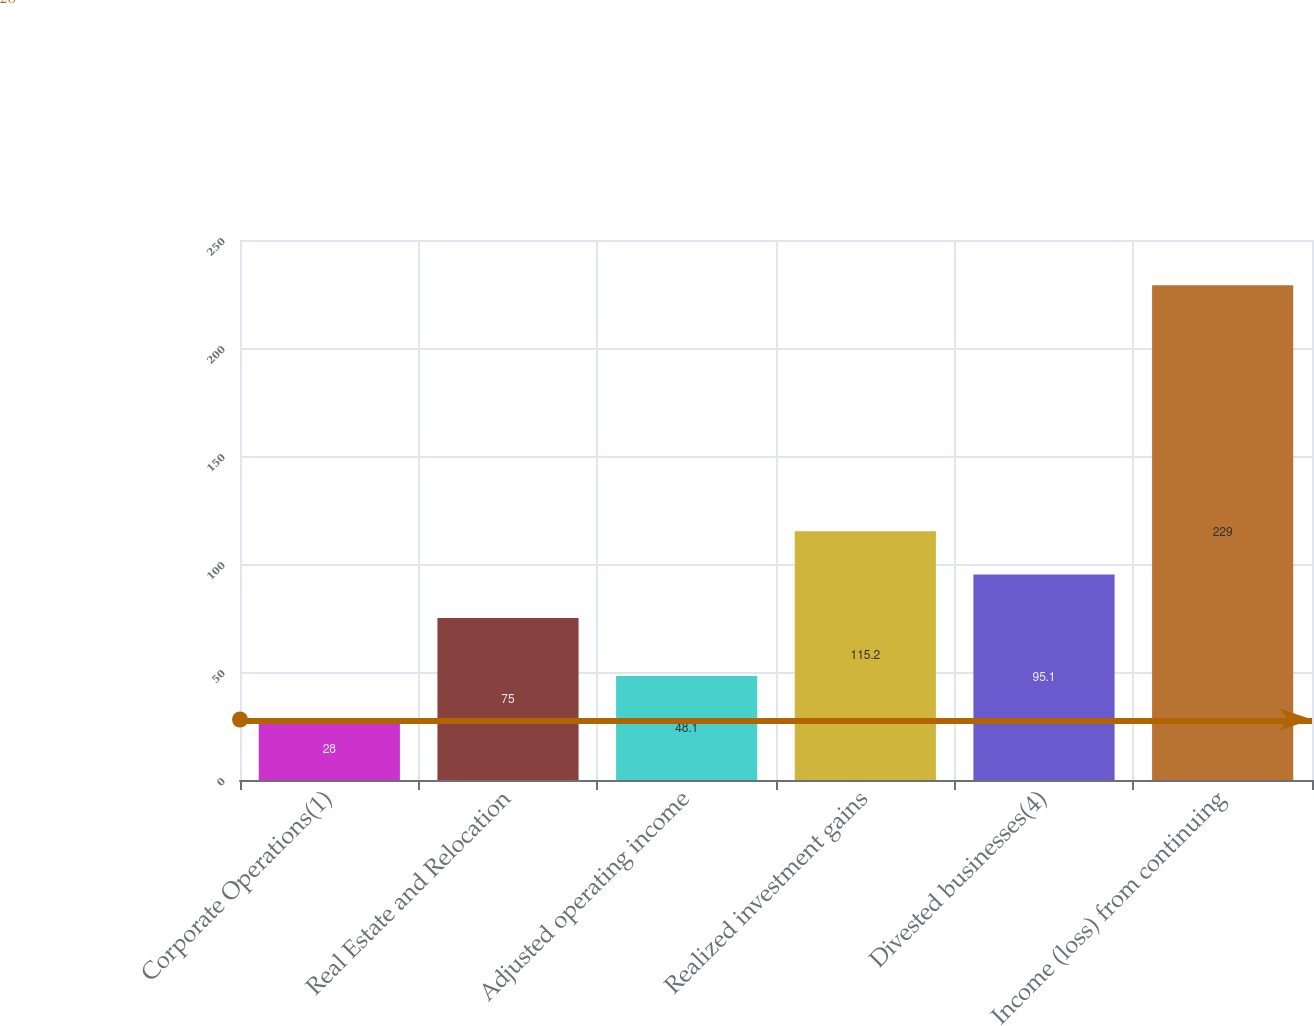<chart> <loc_0><loc_0><loc_500><loc_500><bar_chart><fcel>Corporate Operations(1)<fcel>Real Estate and Relocation<fcel>Adjusted operating income<fcel>Realized investment gains<fcel>Divested businesses(4)<fcel>Income (loss) from continuing<nl><fcel>28<fcel>75<fcel>48.1<fcel>115.2<fcel>95.1<fcel>229<nl></chart> 